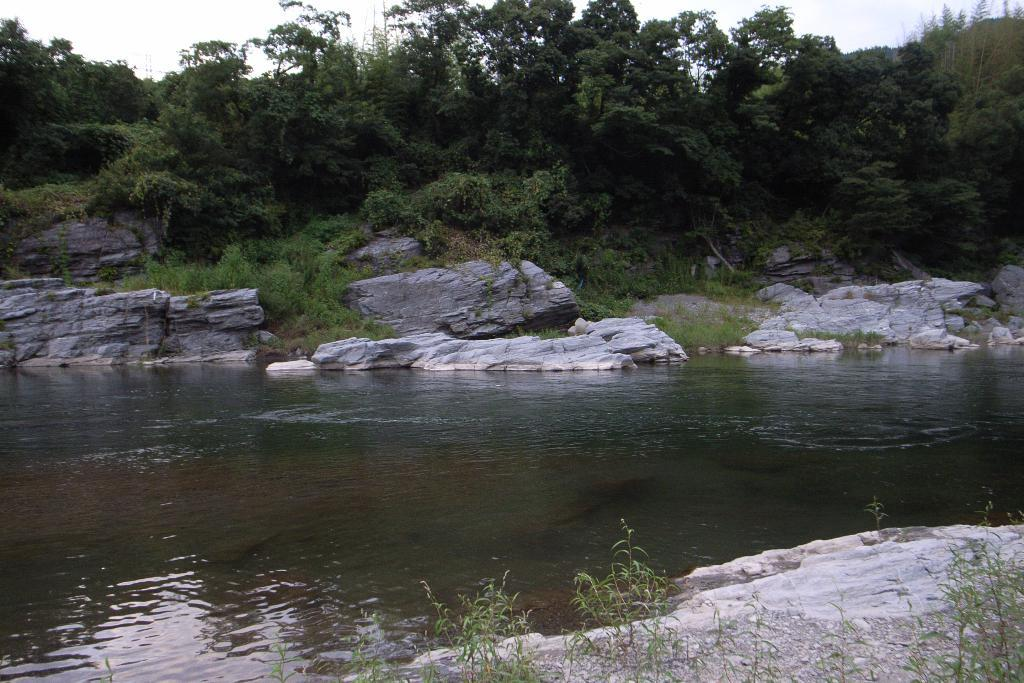What is the main subject in the middle of the picture? There is a lake in the middle of the picture. What can be seen in the background of the picture? There are trees and the sky visible in the background of the picture. What type of behavior can be observed in the tramp in the image? There is no tramp present in the image; it features a lake, trees, and the sky. 